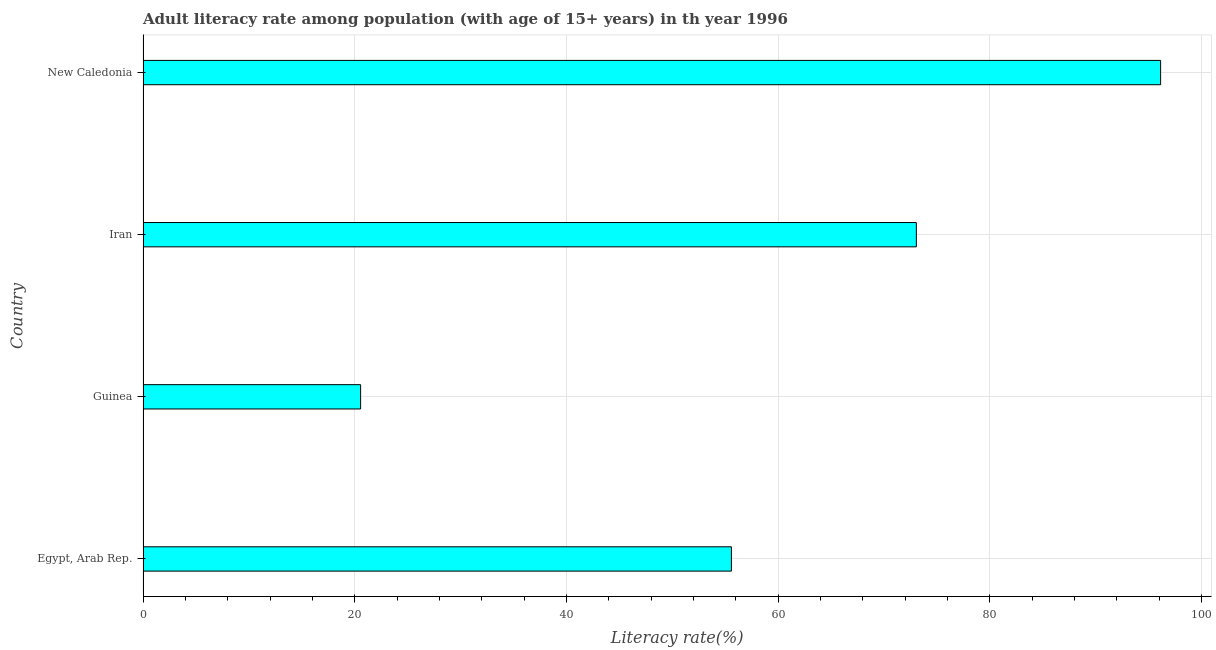Does the graph contain any zero values?
Provide a short and direct response. No. Does the graph contain grids?
Provide a short and direct response. Yes. What is the title of the graph?
Your answer should be very brief. Adult literacy rate among population (with age of 15+ years) in th year 1996. What is the label or title of the X-axis?
Offer a very short reply. Literacy rate(%). What is the adult literacy rate in Guinea?
Give a very brief answer. 20.55. Across all countries, what is the maximum adult literacy rate?
Ensure brevity in your answer.  96.14. Across all countries, what is the minimum adult literacy rate?
Provide a short and direct response. 20.55. In which country was the adult literacy rate maximum?
Ensure brevity in your answer.  New Caledonia. In which country was the adult literacy rate minimum?
Make the answer very short. Guinea. What is the sum of the adult literacy rate?
Provide a succinct answer. 245.34. What is the difference between the adult literacy rate in Guinea and New Caledonia?
Your response must be concise. -75.58. What is the average adult literacy rate per country?
Give a very brief answer. 61.34. What is the median adult literacy rate?
Your answer should be very brief. 64.32. In how many countries, is the adult literacy rate greater than 96 %?
Your answer should be compact. 1. What is the ratio of the adult literacy rate in Iran to that in New Caledonia?
Your response must be concise. 0.76. Is the difference between the adult literacy rate in Iran and New Caledonia greater than the difference between any two countries?
Keep it short and to the point. No. What is the difference between the highest and the second highest adult literacy rate?
Keep it short and to the point. 23.08. What is the difference between the highest and the lowest adult literacy rate?
Keep it short and to the point. 75.58. In how many countries, is the adult literacy rate greater than the average adult literacy rate taken over all countries?
Offer a very short reply. 2. How many bars are there?
Give a very brief answer. 4. Are all the bars in the graph horizontal?
Ensure brevity in your answer.  Yes. How many countries are there in the graph?
Your answer should be compact. 4. What is the difference between two consecutive major ticks on the X-axis?
Provide a succinct answer. 20. What is the Literacy rate(%) of Egypt, Arab Rep.?
Provide a short and direct response. 55.59. What is the Literacy rate(%) of Guinea?
Ensure brevity in your answer.  20.55. What is the Literacy rate(%) in Iran?
Your answer should be compact. 73.06. What is the Literacy rate(%) of New Caledonia?
Make the answer very short. 96.14. What is the difference between the Literacy rate(%) in Egypt, Arab Rep. and Guinea?
Your response must be concise. 35.03. What is the difference between the Literacy rate(%) in Egypt, Arab Rep. and Iran?
Give a very brief answer. -17.47. What is the difference between the Literacy rate(%) in Egypt, Arab Rep. and New Caledonia?
Make the answer very short. -40.55. What is the difference between the Literacy rate(%) in Guinea and Iran?
Ensure brevity in your answer.  -52.51. What is the difference between the Literacy rate(%) in Guinea and New Caledonia?
Offer a terse response. -75.58. What is the difference between the Literacy rate(%) in Iran and New Caledonia?
Your response must be concise. -23.08. What is the ratio of the Literacy rate(%) in Egypt, Arab Rep. to that in Guinea?
Provide a short and direct response. 2.7. What is the ratio of the Literacy rate(%) in Egypt, Arab Rep. to that in Iran?
Provide a short and direct response. 0.76. What is the ratio of the Literacy rate(%) in Egypt, Arab Rep. to that in New Caledonia?
Offer a terse response. 0.58. What is the ratio of the Literacy rate(%) in Guinea to that in Iran?
Make the answer very short. 0.28. What is the ratio of the Literacy rate(%) in Guinea to that in New Caledonia?
Offer a very short reply. 0.21. What is the ratio of the Literacy rate(%) in Iran to that in New Caledonia?
Your answer should be compact. 0.76. 